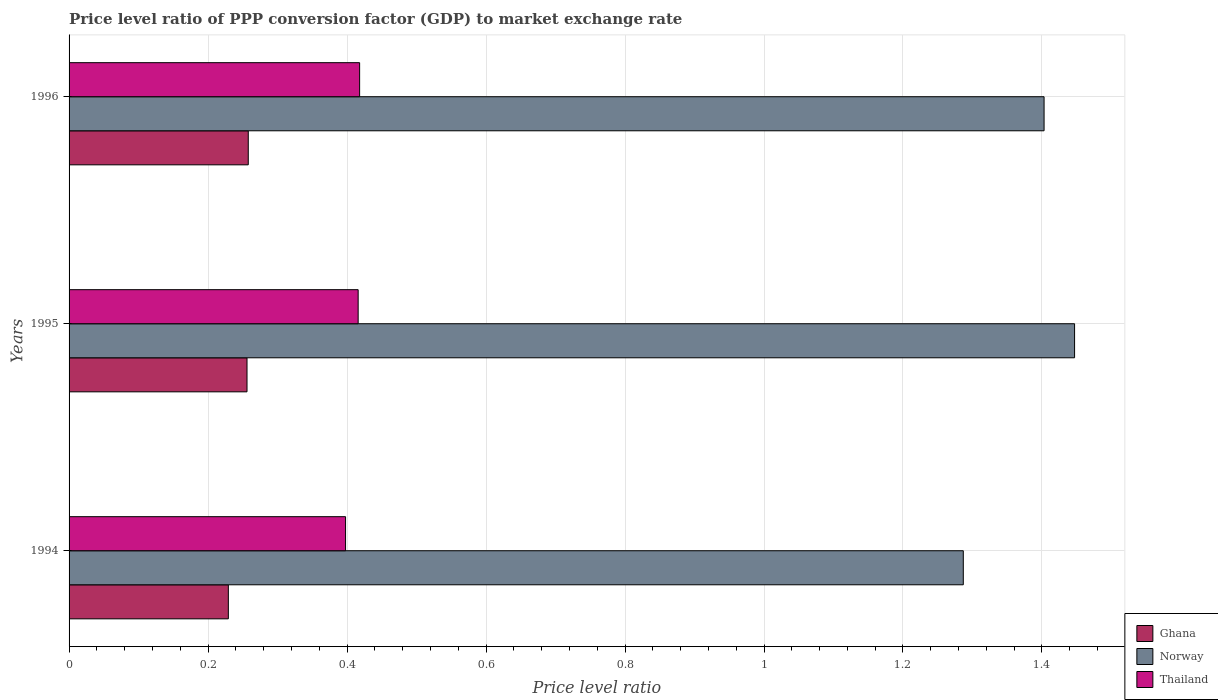How many groups of bars are there?
Make the answer very short. 3. Are the number of bars per tick equal to the number of legend labels?
Give a very brief answer. Yes. How many bars are there on the 1st tick from the top?
Your answer should be compact. 3. How many bars are there on the 1st tick from the bottom?
Provide a short and direct response. 3. In how many cases, is the number of bars for a given year not equal to the number of legend labels?
Your answer should be very brief. 0. What is the price level ratio in Thailand in 1996?
Your response must be concise. 0.42. Across all years, what is the maximum price level ratio in Norway?
Make the answer very short. 1.45. Across all years, what is the minimum price level ratio in Thailand?
Ensure brevity in your answer.  0.4. In which year was the price level ratio in Thailand minimum?
Your answer should be compact. 1994. What is the total price level ratio in Norway in the graph?
Offer a very short reply. 4.14. What is the difference between the price level ratio in Thailand in 1994 and that in 1996?
Provide a succinct answer. -0.02. What is the difference between the price level ratio in Thailand in 1996 and the price level ratio in Norway in 1995?
Keep it short and to the point. -1.03. What is the average price level ratio in Norway per year?
Offer a very short reply. 1.38. In the year 1994, what is the difference between the price level ratio in Ghana and price level ratio in Thailand?
Offer a terse response. -0.17. In how many years, is the price level ratio in Norway greater than 0.4 ?
Make the answer very short. 3. What is the ratio of the price level ratio in Thailand in 1995 to that in 1996?
Keep it short and to the point. 0.99. What is the difference between the highest and the second highest price level ratio in Ghana?
Provide a succinct answer. 0. What is the difference between the highest and the lowest price level ratio in Norway?
Keep it short and to the point. 0.16. Is the sum of the price level ratio in Ghana in 1994 and 1995 greater than the maximum price level ratio in Thailand across all years?
Keep it short and to the point. Yes. What does the 2nd bar from the top in 1995 represents?
Give a very brief answer. Norway. How many bars are there?
Provide a succinct answer. 9. How many years are there in the graph?
Offer a very short reply. 3. How many legend labels are there?
Offer a very short reply. 3. How are the legend labels stacked?
Ensure brevity in your answer.  Vertical. What is the title of the graph?
Offer a terse response. Price level ratio of PPP conversion factor (GDP) to market exchange rate. What is the label or title of the X-axis?
Keep it short and to the point. Price level ratio. What is the label or title of the Y-axis?
Ensure brevity in your answer.  Years. What is the Price level ratio of Ghana in 1994?
Your answer should be compact. 0.23. What is the Price level ratio of Norway in 1994?
Make the answer very short. 1.29. What is the Price level ratio in Thailand in 1994?
Offer a terse response. 0.4. What is the Price level ratio of Ghana in 1995?
Your answer should be very brief. 0.26. What is the Price level ratio of Norway in 1995?
Provide a succinct answer. 1.45. What is the Price level ratio of Thailand in 1995?
Your response must be concise. 0.42. What is the Price level ratio in Ghana in 1996?
Give a very brief answer. 0.26. What is the Price level ratio in Norway in 1996?
Provide a short and direct response. 1.4. What is the Price level ratio of Thailand in 1996?
Your answer should be very brief. 0.42. Across all years, what is the maximum Price level ratio of Ghana?
Offer a very short reply. 0.26. Across all years, what is the maximum Price level ratio in Norway?
Ensure brevity in your answer.  1.45. Across all years, what is the maximum Price level ratio in Thailand?
Ensure brevity in your answer.  0.42. Across all years, what is the minimum Price level ratio in Ghana?
Keep it short and to the point. 0.23. Across all years, what is the minimum Price level ratio in Norway?
Offer a very short reply. 1.29. Across all years, what is the minimum Price level ratio of Thailand?
Keep it short and to the point. 0.4. What is the total Price level ratio in Ghana in the graph?
Provide a succinct answer. 0.74. What is the total Price level ratio of Norway in the graph?
Your answer should be compact. 4.14. What is the total Price level ratio in Thailand in the graph?
Make the answer very short. 1.23. What is the difference between the Price level ratio in Ghana in 1994 and that in 1995?
Your answer should be compact. -0.03. What is the difference between the Price level ratio of Norway in 1994 and that in 1995?
Offer a very short reply. -0.16. What is the difference between the Price level ratio of Thailand in 1994 and that in 1995?
Provide a succinct answer. -0.02. What is the difference between the Price level ratio in Ghana in 1994 and that in 1996?
Offer a very short reply. -0.03. What is the difference between the Price level ratio in Norway in 1994 and that in 1996?
Your answer should be very brief. -0.12. What is the difference between the Price level ratio in Thailand in 1994 and that in 1996?
Provide a short and direct response. -0.02. What is the difference between the Price level ratio in Ghana in 1995 and that in 1996?
Offer a terse response. -0. What is the difference between the Price level ratio of Norway in 1995 and that in 1996?
Your answer should be very brief. 0.04. What is the difference between the Price level ratio of Thailand in 1995 and that in 1996?
Your answer should be very brief. -0. What is the difference between the Price level ratio in Ghana in 1994 and the Price level ratio in Norway in 1995?
Your answer should be compact. -1.22. What is the difference between the Price level ratio of Ghana in 1994 and the Price level ratio of Thailand in 1995?
Make the answer very short. -0.19. What is the difference between the Price level ratio of Norway in 1994 and the Price level ratio of Thailand in 1995?
Your answer should be very brief. 0.87. What is the difference between the Price level ratio in Ghana in 1994 and the Price level ratio in Norway in 1996?
Your response must be concise. -1.17. What is the difference between the Price level ratio of Ghana in 1994 and the Price level ratio of Thailand in 1996?
Give a very brief answer. -0.19. What is the difference between the Price level ratio of Norway in 1994 and the Price level ratio of Thailand in 1996?
Offer a very short reply. 0.87. What is the difference between the Price level ratio in Ghana in 1995 and the Price level ratio in Norway in 1996?
Provide a short and direct response. -1.15. What is the difference between the Price level ratio in Ghana in 1995 and the Price level ratio in Thailand in 1996?
Make the answer very short. -0.16. What is the difference between the Price level ratio in Norway in 1995 and the Price level ratio in Thailand in 1996?
Make the answer very short. 1.03. What is the average Price level ratio in Ghana per year?
Your response must be concise. 0.25. What is the average Price level ratio in Norway per year?
Make the answer very short. 1.38. What is the average Price level ratio of Thailand per year?
Ensure brevity in your answer.  0.41. In the year 1994, what is the difference between the Price level ratio in Ghana and Price level ratio in Norway?
Your answer should be very brief. -1.06. In the year 1994, what is the difference between the Price level ratio of Ghana and Price level ratio of Thailand?
Ensure brevity in your answer.  -0.17. In the year 1995, what is the difference between the Price level ratio of Ghana and Price level ratio of Norway?
Your response must be concise. -1.19. In the year 1995, what is the difference between the Price level ratio in Ghana and Price level ratio in Thailand?
Ensure brevity in your answer.  -0.16. In the year 1995, what is the difference between the Price level ratio of Norway and Price level ratio of Thailand?
Give a very brief answer. 1.03. In the year 1996, what is the difference between the Price level ratio in Ghana and Price level ratio in Norway?
Provide a succinct answer. -1.15. In the year 1996, what is the difference between the Price level ratio in Ghana and Price level ratio in Thailand?
Your answer should be very brief. -0.16. In the year 1996, what is the difference between the Price level ratio of Norway and Price level ratio of Thailand?
Offer a very short reply. 0.98. What is the ratio of the Price level ratio of Ghana in 1994 to that in 1995?
Your response must be concise. 0.9. What is the ratio of the Price level ratio in Norway in 1994 to that in 1995?
Offer a very short reply. 0.89. What is the ratio of the Price level ratio of Thailand in 1994 to that in 1995?
Provide a short and direct response. 0.96. What is the ratio of the Price level ratio of Ghana in 1994 to that in 1996?
Make the answer very short. 0.89. What is the ratio of the Price level ratio of Norway in 1994 to that in 1996?
Give a very brief answer. 0.92. What is the ratio of the Price level ratio of Thailand in 1994 to that in 1996?
Offer a very short reply. 0.95. What is the ratio of the Price level ratio of Norway in 1995 to that in 1996?
Your response must be concise. 1.03. What is the difference between the highest and the second highest Price level ratio of Ghana?
Provide a succinct answer. 0. What is the difference between the highest and the second highest Price level ratio of Norway?
Offer a very short reply. 0.04. What is the difference between the highest and the second highest Price level ratio of Thailand?
Give a very brief answer. 0. What is the difference between the highest and the lowest Price level ratio of Ghana?
Your response must be concise. 0.03. What is the difference between the highest and the lowest Price level ratio in Norway?
Provide a short and direct response. 0.16. What is the difference between the highest and the lowest Price level ratio of Thailand?
Make the answer very short. 0.02. 